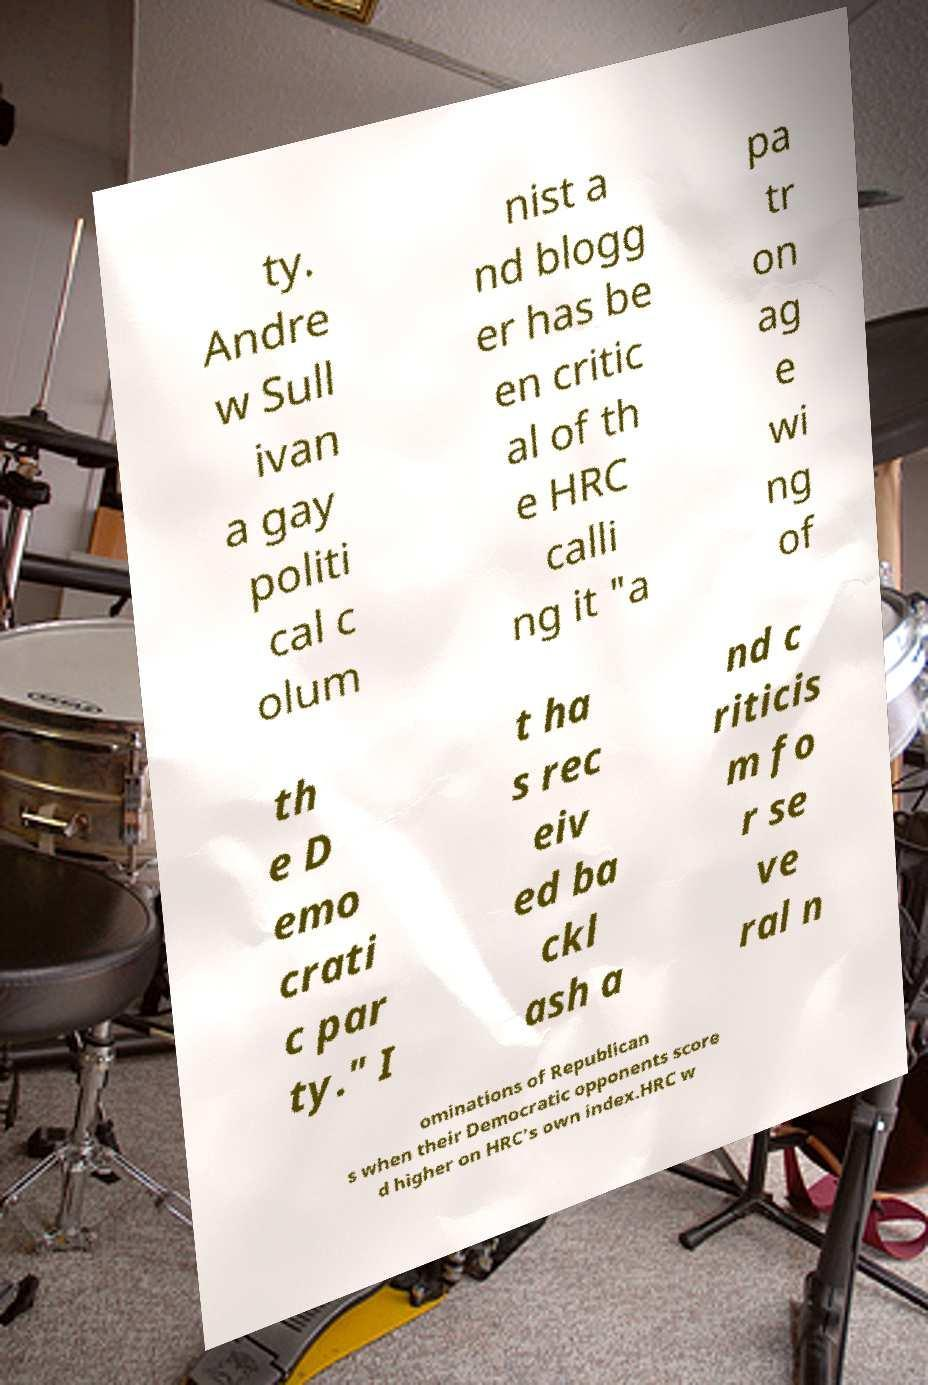Please identify and transcribe the text found in this image. ty. Andre w Sull ivan a gay politi cal c olum nist a nd blogg er has be en critic al of th e HRC calli ng it "a pa tr on ag e wi ng of th e D emo crati c par ty." I t ha s rec eiv ed ba ckl ash a nd c riticis m fo r se ve ral n ominations of Republican s when their Democratic opponents score d higher on HRC's own index.HRC w 